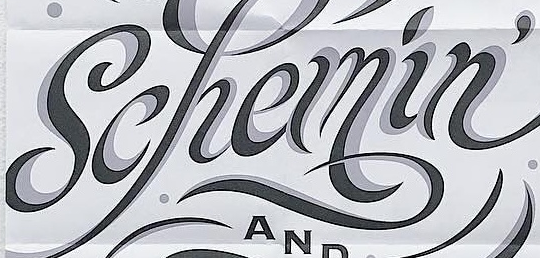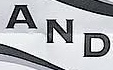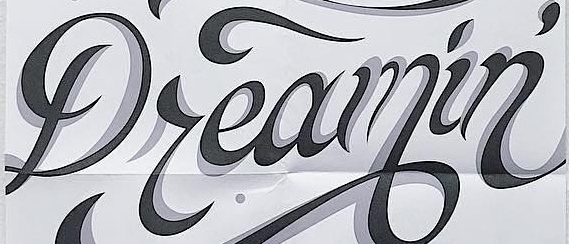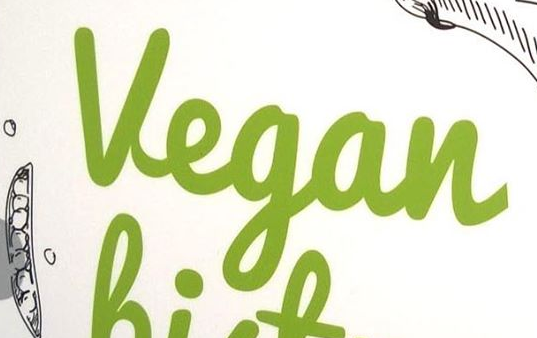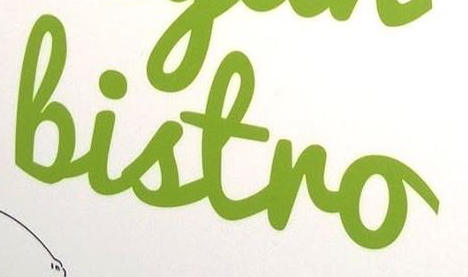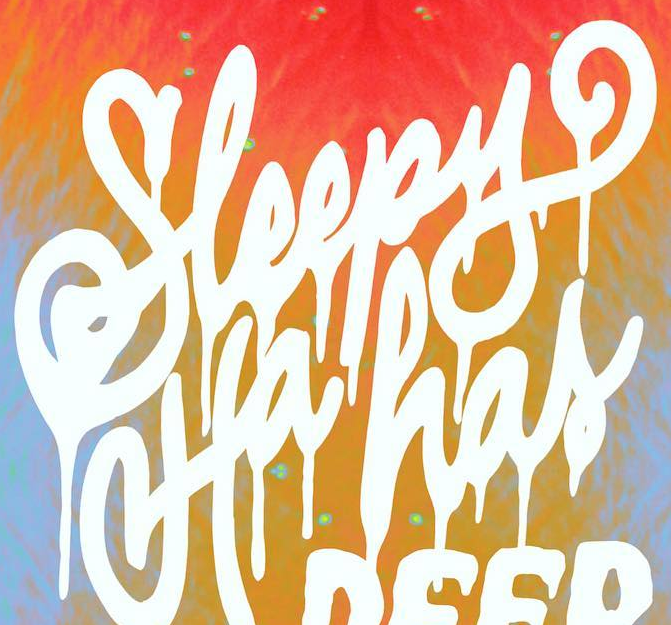Read the text from these images in sequence, separated by a semicolon. Schemin'; AND; Dreamin'; Vegan; Bistro; Sleepy 